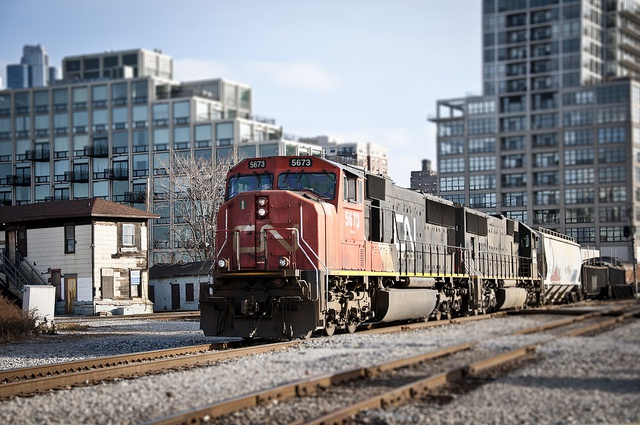Describe the objects in this image and their specific colors. I can see a train in darkgray, black, maroon, and gray tones in this image. 